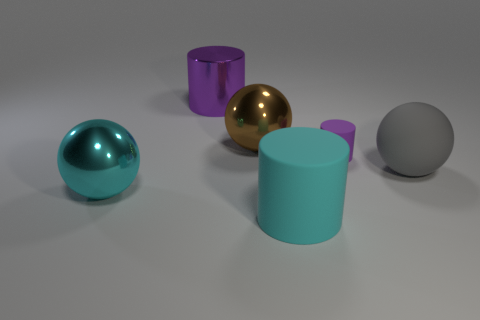Add 1 purple shiny cubes. How many objects exist? 7 Subtract all brown metal balls. Subtract all large purple cylinders. How many objects are left? 4 Add 1 big brown metallic objects. How many big brown metallic objects are left? 2 Add 3 cylinders. How many cylinders exist? 6 Subtract 0 gray cylinders. How many objects are left? 6 